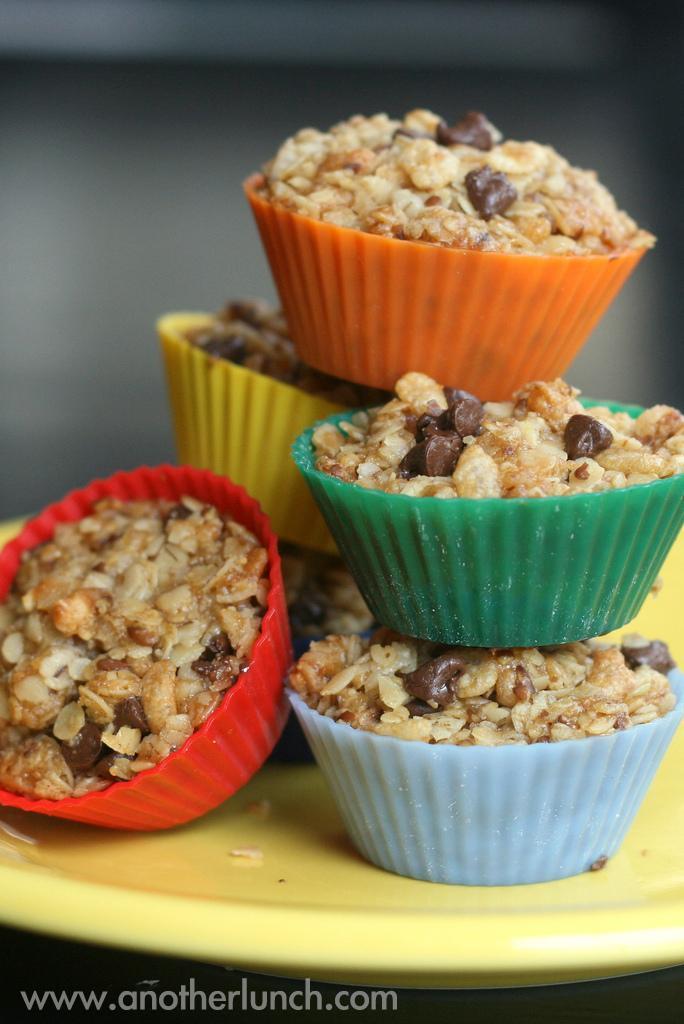Can you describe this image briefly? In this image we can see some food items are placed on the plate. There is a plate which is yellow in color. 